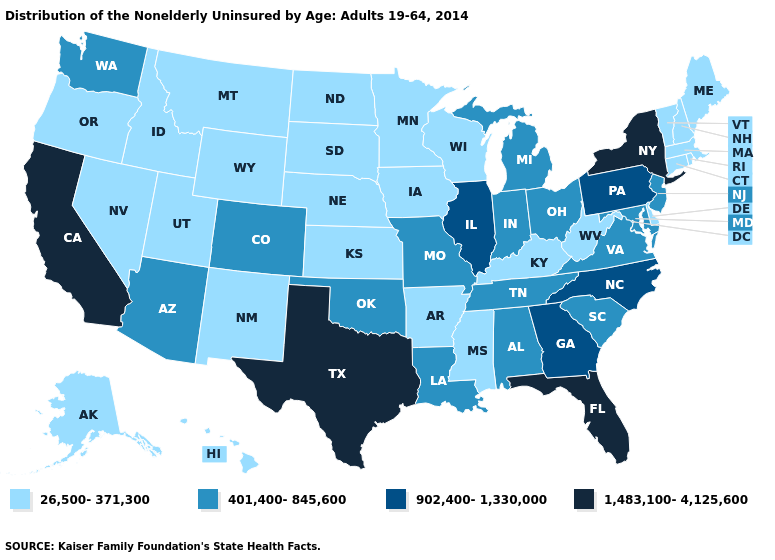Does Wisconsin have the highest value in the USA?
Quick response, please. No. Name the states that have a value in the range 26,500-371,300?
Write a very short answer. Alaska, Arkansas, Connecticut, Delaware, Hawaii, Idaho, Iowa, Kansas, Kentucky, Maine, Massachusetts, Minnesota, Mississippi, Montana, Nebraska, Nevada, New Hampshire, New Mexico, North Dakota, Oregon, Rhode Island, South Dakota, Utah, Vermont, West Virginia, Wisconsin, Wyoming. What is the value of Nevada?
Keep it brief. 26,500-371,300. Does the map have missing data?
Be succinct. No. What is the highest value in the MidWest ?
Keep it brief. 902,400-1,330,000. Name the states that have a value in the range 902,400-1,330,000?
Quick response, please. Georgia, Illinois, North Carolina, Pennsylvania. Does New Jersey have a higher value than Pennsylvania?
Write a very short answer. No. Is the legend a continuous bar?
Be succinct. No. How many symbols are there in the legend?
Give a very brief answer. 4. What is the lowest value in the USA?
Write a very short answer. 26,500-371,300. What is the value of Georgia?
Give a very brief answer. 902,400-1,330,000. What is the value of Wyoming?
Write a very short answer. 26,500-371,300. What is the value of North Dakota?
Be succinct. 26,500-371,300. What is the value of Georgia?
Give a very brief answer. 902,400-1,330,000. Name the states that have a value in the range 1,483,100-4,125,600?
Be succinct. California, Florida, New York, Texas. 